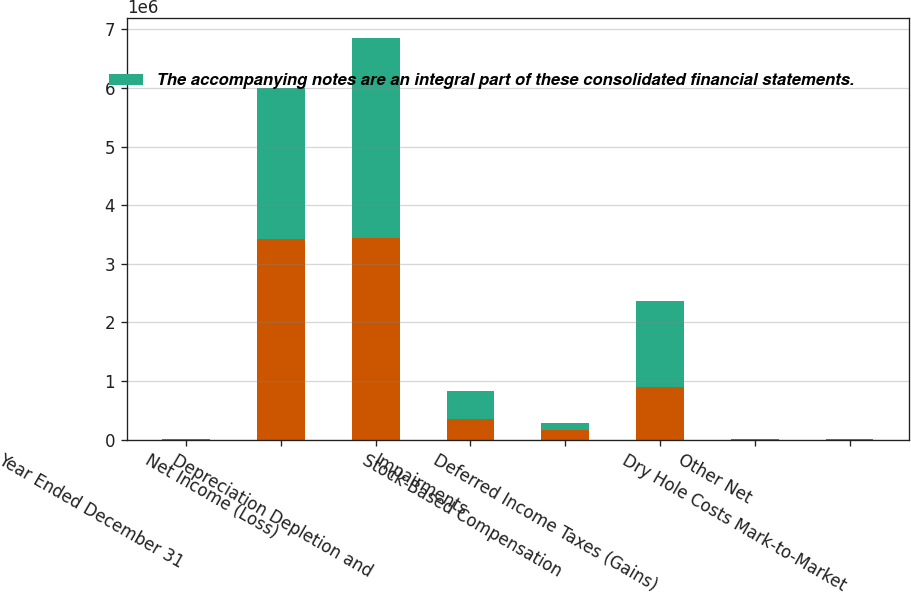Convert chart to OTSL. <chart><loc_0><loc_0><loc_500><loc_500><stacked_bar_chart><ecel><fcel>Year Ended December 31<fcel>Net Income (Loss)<fcel>Depreciation Depletion and<fcel>Impairments<fcel>Stock-Based Compensation<fcel>Deferred Income Taxes (Gains)<fcel>Other Net<fcel>Dry Hole Costs Mark-to-Market<nl><fcel>nan<fcel>2018<fcel>3.41904e+06<fcel>3.43541e+06<fcel>347021<fcel>155337<fcel>894156<fcel>7066<fcel>5405<nl><fcel>The accompanying notes are an integral part of these consolidated financial statements.<fcel>2017<fcel>2.58258e+06<fcel>3.40939e+06<fcel>479240<fcel>133849<fcel>1.47387e+06<fcel>6546<fcel>4609<nl></chart> 